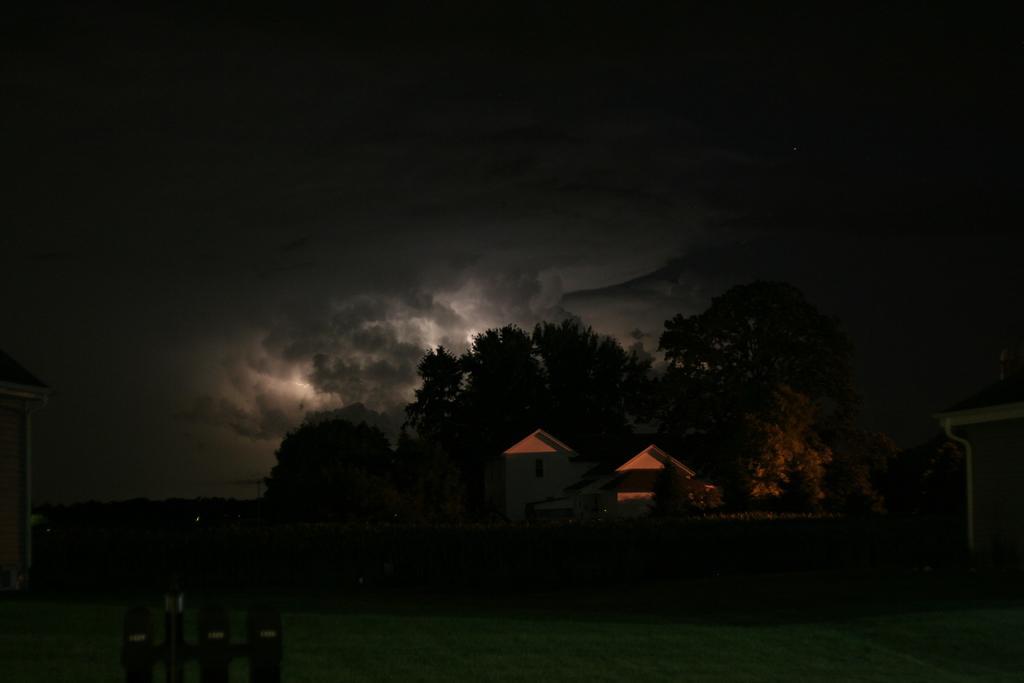Describe this image in one or two sentences. There is a building. Back of the building there are trees. In the background there is sky with clouds. On the sides there are buildings. 